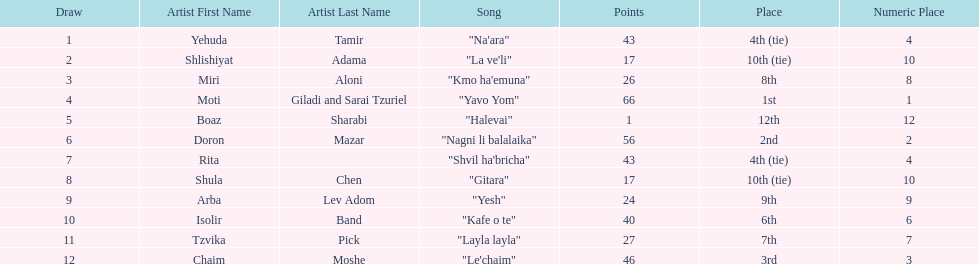Which artist had almost no points? Boaz Sharabi. 